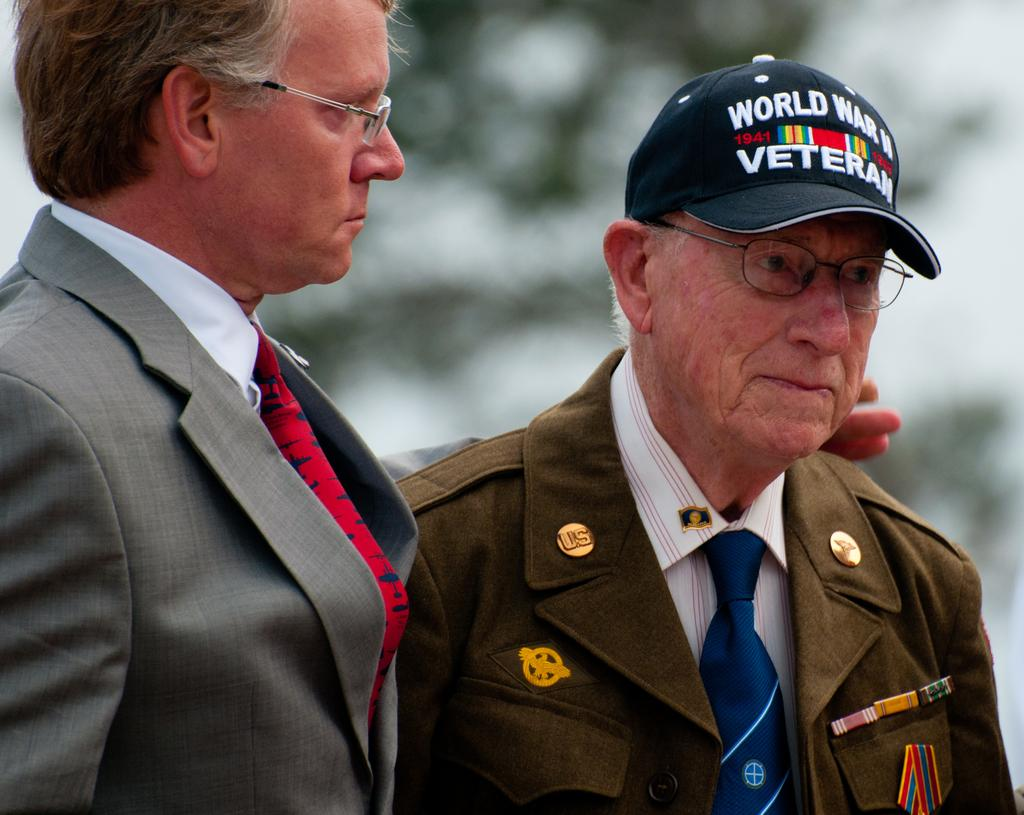What type of accessory is visible in the image? There is a cap in the image. What other items can be seen in the image? There are badges in the image. What clothing items are the two men wearing? The two men are wearing blazers, ties, and spectacles. Can you describe the background of the image? The background of the image is blurry. What type of zephyr can be seen blowing through the image? There is no zephyr present in the image; it is a still image. What part of the men's bodies are covered by their ties? The ties are worn around the necks of the men, covering the upper part of their shirts. 